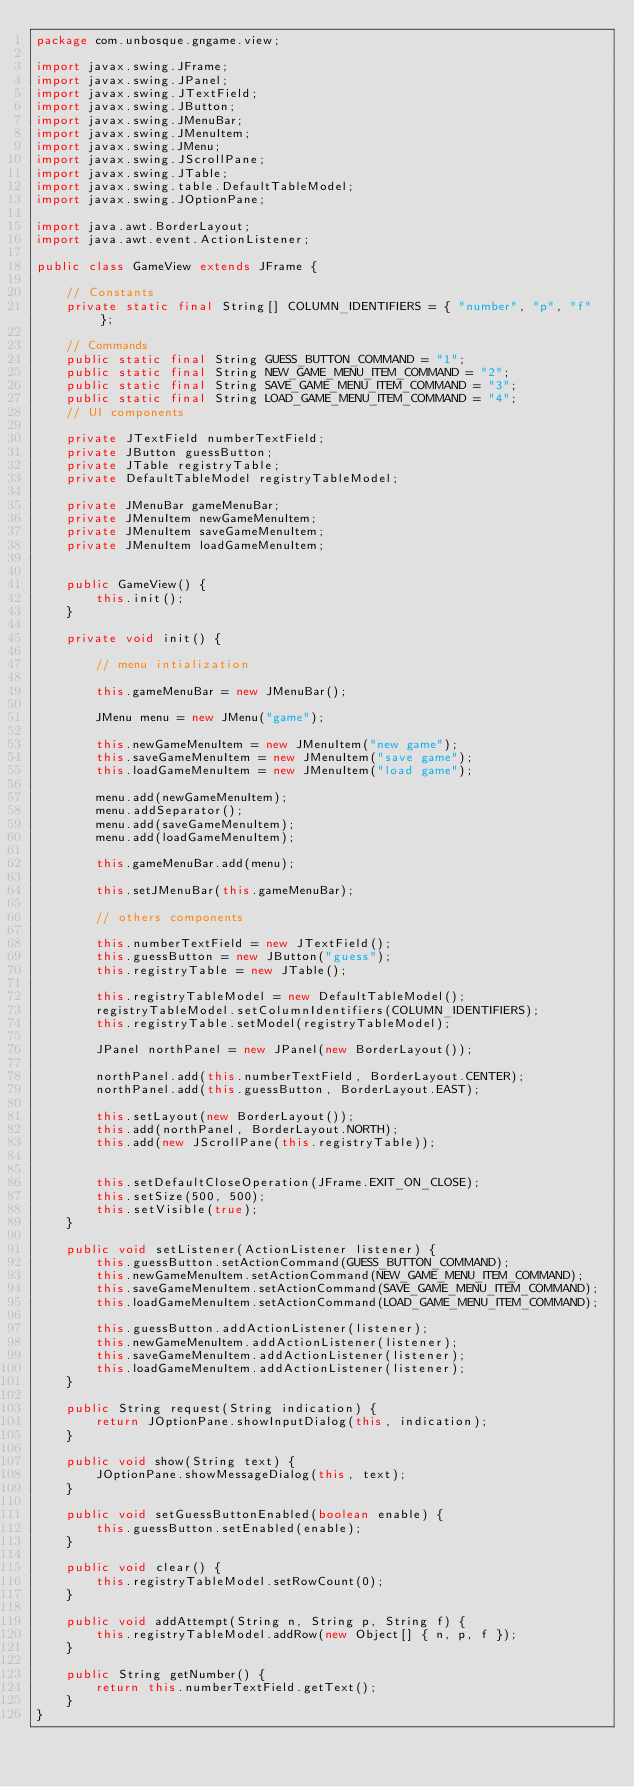<code> <loc_0><loc_0><loc_500><loc_500><_Java_>package com.unbosque.gngame.view;

import javax.swing.JFrame;
import javax.swing.JPanel;
import javax.swing.JTextField;
import javax.swing.JButton;
import javax.swing.JMenuBar;
import javax.swing.JMenuItem;
import javax.swing.JMenu;
import javax.swing.JScrollPane;
import javax.swing.JTable;
import javax.swing.table.DefaultTableModel;
import javax.swing.JOptionPane;

import java.awt.BorderLayout;
import java.awt.event.ActionListener;

public class GameView extends JFrame {

    // Constants
    private static final String[] COLUMN_IDENTIFIERS = { "number", "p", "f" };

    // Commands
    public static final String GUESS_BUTTON_COMMAND = "1";
    public static final String NEW_GAME_MENU_ITEM_COMMAND = "2";
    public static final String SAVE_GAME_MENU_ITEM_COMMAND = "3";
    public static final String LOAD_GAME_MENU_ITEM_COMMAND = "4";
    // UI components

    private JTextField numberTextField;
    private JButton guessButton;
    private JTable registryTable;
    private DefaultTableModel registryTableModel;

    private JMenuBar gameMenuBar;
    private JMenuItem newGameMenuItem;
    private JMenuItem saveGameMenuItem;
    private JMenuItem loadGameMenuItem;


    public GameView() {
        this.init();
    }  

    private void init() {

        // menu intialization

        this.gameMenuBar = new JMenuBar();

        JMenu menu = new JMenu("game");        

        this.newGameMenuItem = new JMenuItem("new game");        
        this.saveGameMenuItem = new JMenuItem("save game");
        this.loadGameMenuItem = new JMenuItem("load game");

        menu.add(newGameMenuItem);
        menu.addSeparator();
        menu.add(saveGameMenuItem);
        menu.add(loadGameMenuItem);

        this.gameMenuBar.add(menu);

        this.setJMenuBar(this.gameMenuBar);

        // others components

        this.numberTextField = new JTextField();
        this.guessButton = new JButton("guess");
        this.registryTable = new JTable();

        this.registryTableModel = new DefaultTableModel();
        registryTableModel.setColumnIdentifiers(COLUMN_IDENTIFIERS);
        this.registryTable.setModel(registryTableModel);

        JPanel northPanel = new JPanel(new BorderLayout());

        northPanel.add(this.numberTextField, BorderLayout.CENTER);
        northPanel.add(this.guessButton, BorderLayout.EAST);

        this.setLayout(new BorderLayout());
        this.add(northPanel, BorderLayout.NORTH);
        this.add(new JScrollPane(this.registryTable));
        

        this.setDefaultCloseOperation(JFrame.EXIT_ON_CLOSE);
        this.setSize(500, 500);
        this.setVisible(true);
    }

    public void setListener(ActionListener listener) {
        this.guessButton.setActionCommand(GUESS_BUTTON_COMMAND);
        this.newGameMenuItem.setActionCommand(NEW_GAME_MENU_ITEM_COMMAND);
        this.saveGameMenuItem.setActionCommand(SAVE_GAME_MENU_ITEM_COMMAND);
        this.loadGameMenuItem.setActionCommand(LOAD_GAME_MENU_ITEM_COMMAND);

        this.guessButton.addActionListener(listener);
        this.newGameMenuItem.addActionListener(listener);
        this.saveGameMenuItem.addActionListener(listener);
        this.loadGameMenuItem.addActionListener(listener);
    } 

    public String request(String indication) {
        return JOptionPane.showInputDialog(this, indication);
    }

    public void show(String text) {
        JOptionPane.showMessageDialog(this, text);
    }

    public void setGuessButtonEnabled(boolean enable) {
        this.guessButton.setEnabled(enable);
    } 

    public void clear() {
        this.registryTableModel.setRowCount(0);
    }

    public void addAttempt(String n, String p, String f) {
        this.registryTableModel.addRow(new Object[] { n, p, f });
    }

    public String getNumber() {
        return this.numberTextField.getText();
    }
}</code> 